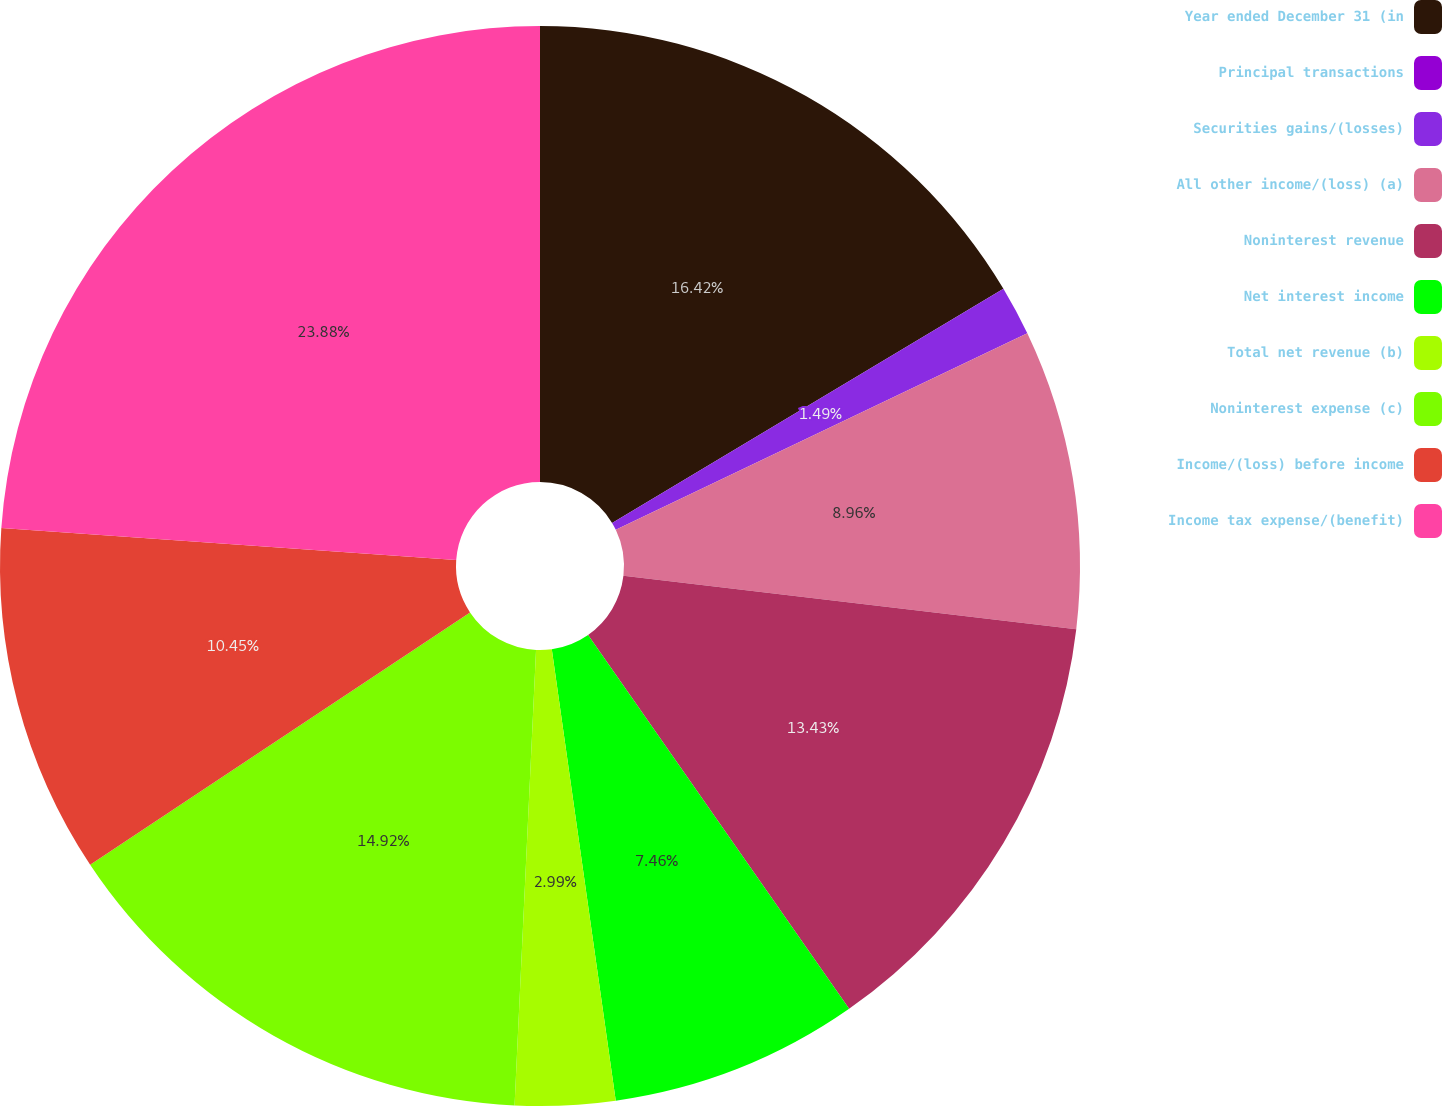<chart> <loc_0><loc_0><loc_500><loc_500><pie_chart><fcel>Year ended December 31 (in<fcel>Principal transactions<fcel>Securities gains/(losses)<fcel>All other income/(loss) (a)<fcel>Noninterest revenue<fcel>Net interest income<fcel>Total net revenue (b)<fcel>Noninterest expense (c)<fcel>Income/(loss) before income<fcel>Income tax expense/(benefit)<nl><fcel>16.42%<fcel>0.0%<fcel>1.49%<fcel>8.96%<fcel>13.43%<fcel>7.46%<fcel>2.99%<fcel>14.92%<fcel>10.45%<fcel>23.88%<nl></chart> 